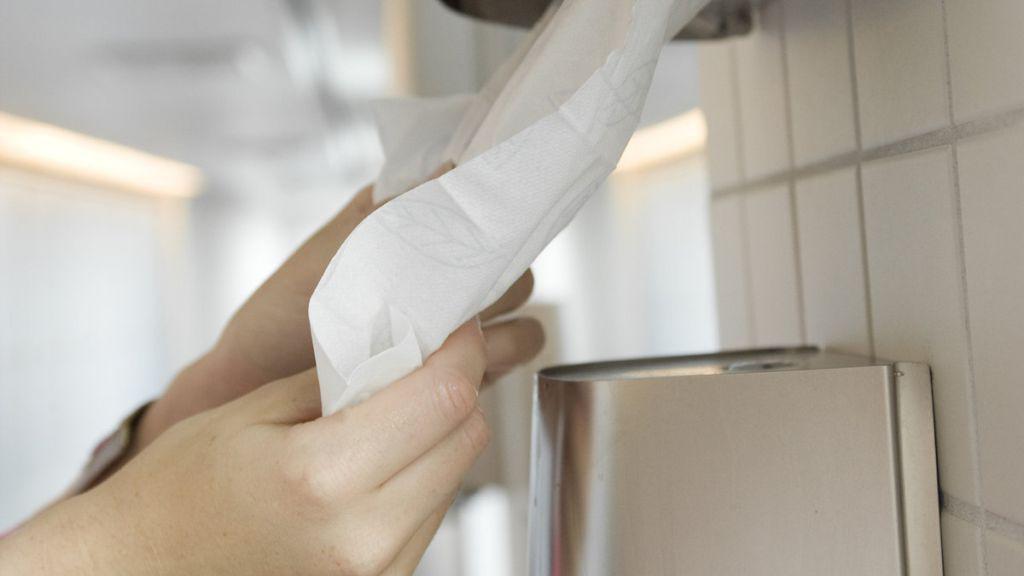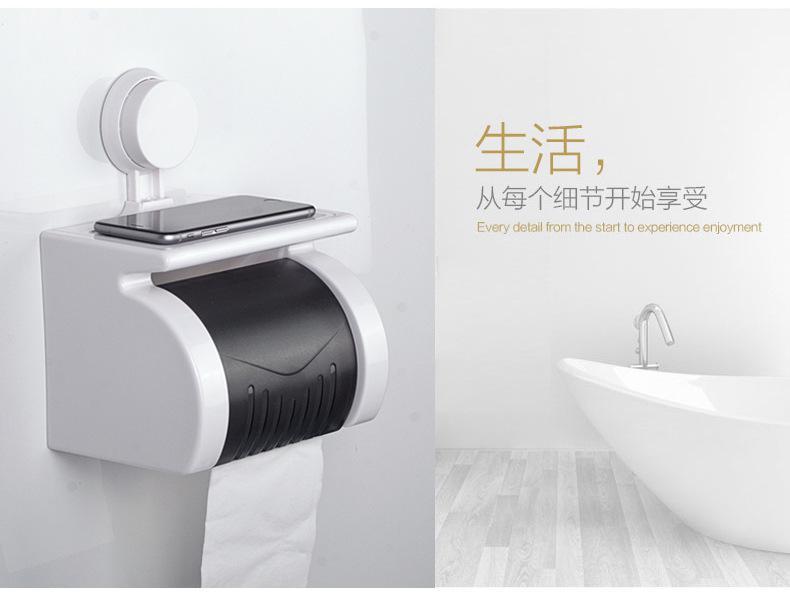The first image is the image on the left, the second image is the image on the right. Examine the images to the left and right. Is the description "A hand is reaching toward a white towel in a dispenser." accurate? Answer yes or no. Yes. The first image is the image on the left, the second image is the image on the right. Analyze the images presented: Is the assertion "The image on the left shows a human hand holding a paper towel." valid? Answer yes or no. Yes. 